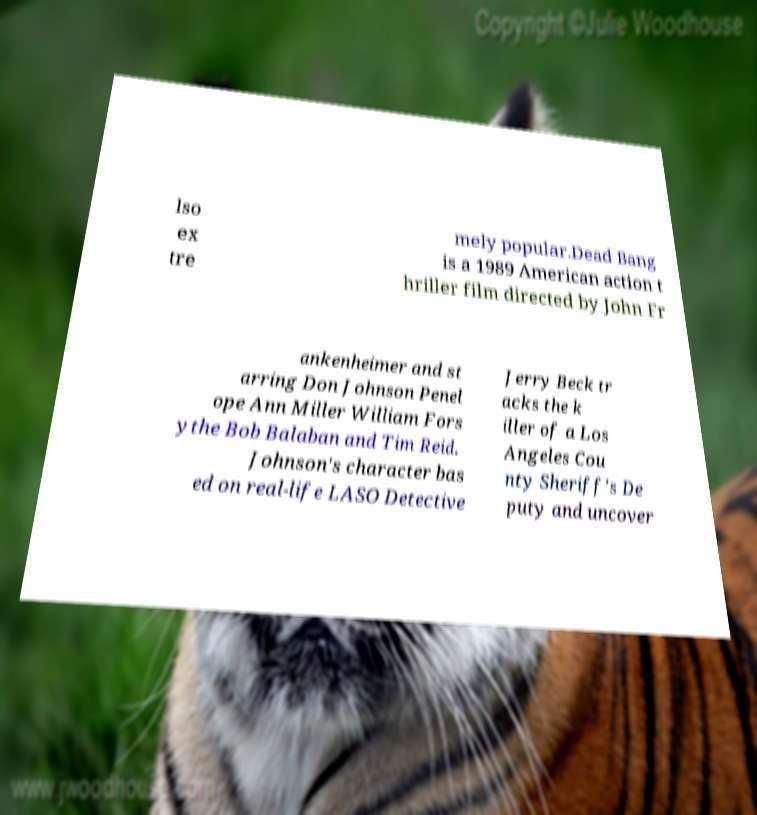Can you accurately transcribe the text from the provided image for me? lso ex tre mely popular.Dead Bang is a 1989 American action t hriller film directed by John Fr ankenheimer and st arring Don Johnson Penel ope Ann Miller William Fors ythe Bob Balaban and Tim Reid. Johnson's character bas ed on real-life LASO Detective Jerry Beck tr acks the k iller of a Los Angeles Cou nty Sheriff's De puty and uncover 